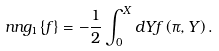<formula> <loc_0><loc_0><loc_500><loc_500>\ n n g _ { 1 } \{ f \} = - \frac { 1 } { 2 } \int _ { 0 } ^ { X } d Y f \left ( \pi , Y \right ) .</formula> 